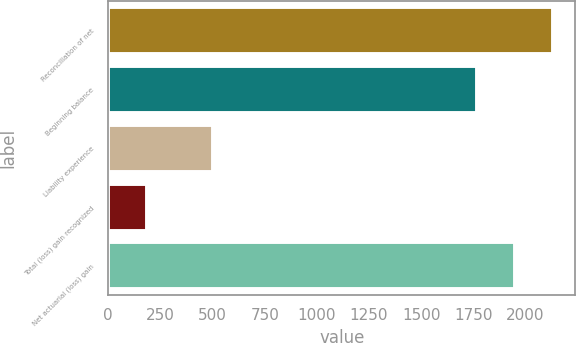<chart> <loc_0><loc_0><loc_500><loc_500><bar_chart><fcel>Reconciliation of net<fcel>Beginning balance<fcel>Liability experience<fcel>Total (loss) gain recognized<fcel>Net actuarial (loss) gain<nl><fcel>2132.6<fcel>1766<fcel>502<fcel>185<fcel>1949.3<nl></chart> 